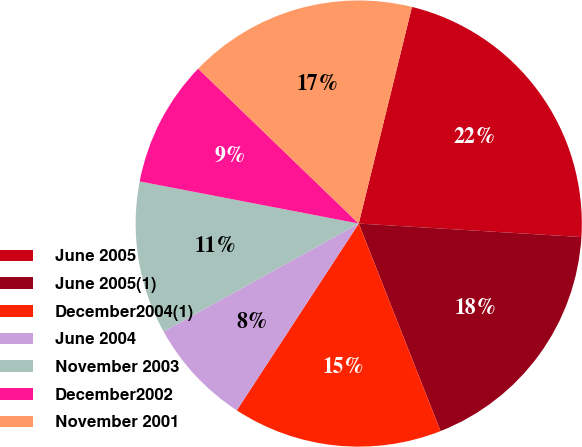<chart> <loc_0><loc_0><loc_500><loc_500><pie_chart><fcel>June 2005<fcel>June 2005(1)<fcel>December2004(1)<fcel>June 2004<fcel>November 2003<fcel>December2002<fcel>November 2001<nl><fcel>22.13%<fcel>18.06%<fcel>15.18%<fcel>7.75%<fcel>11.07%<fcel>9.19%<fcel>16.62%<nl></chart> 